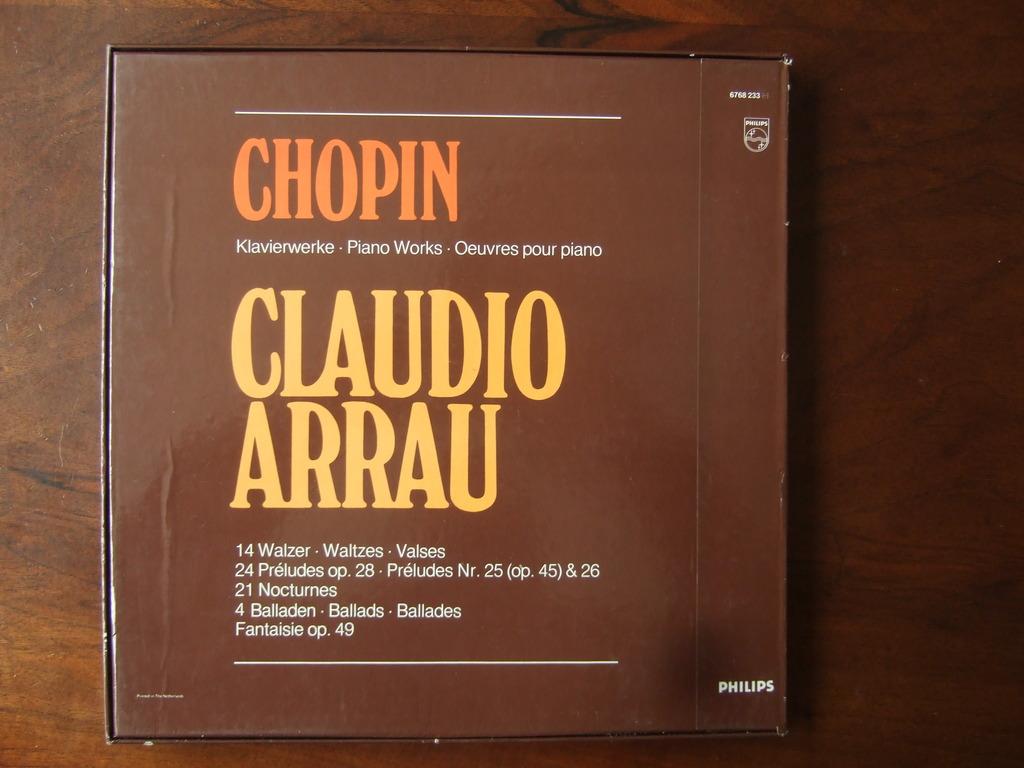What brand is printed at the bottom right?
Ensure brevity in your answer.  Philips. 